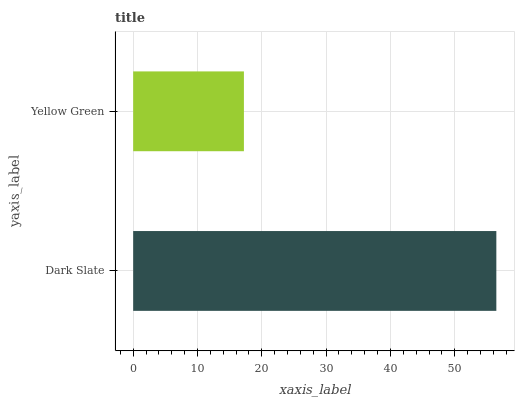Is Yellow Green the minimum?
Answer yes or no. Yes. Is Dark Slate the maximum?
Answer yes or no. Yes. Is Yellow Green the maximum?
Answer yes or no. No. Is Dark Slate greater than Yellow Green?
Answer yes or no. Yes. Is Yellow Green less than Dark Slate?
Answer yes or no. Yes. Is Yellow Green greater than Dark Slate?
Answer yes or no. No. Is Dark Slate less than Yellow Green?
Answer yes or no. No. Is Dark Slate the high median?
Answer yes or no. Yes. Is Yellow Green the low median?
Answer yes or no. Yes. Is Yellow Green the high median?
Answer yes or no. No. Is Dark Slate the low median?
Answer yes or no. No. 